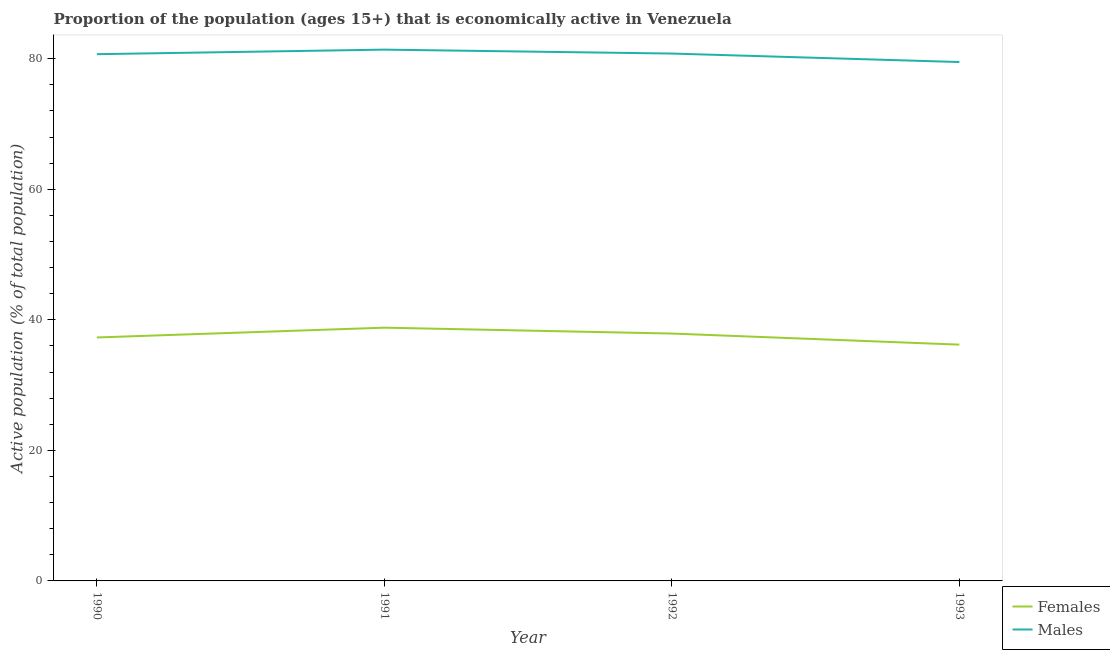What is the percentage of economically active female population in 1991?
Give a very brief answer. 38.8. Across all years, what is the maximum percentage of economically active female population?
Your answer should be very brief. 38.8. Across all years, what is the minimum percentage of economically active female population?
Ensure brevity in your answer.  36.2. In which year was the percentage of economically active male population maximum?
Ensure brevity in your answer.  1991. What is the total percentage of economically active female population in the graph?
Your answer should be very brief. 150.2. What is the difference between the percentage of economically active female population in 1990 and that in 1992?
Give a very brief answer. -0.6. What is the difference between the percentage of economically active male population in 1991 and the percentage of economically active female population in 1993?
Your answer should be compact. 45.2. What is the average percentage of economically active male population per year?
Ensure brevity in your answer.  80.6. In the year 1991, what is the difference between the percentage of economically active female population and percentage of economically active male population?
Make the answer very short. -42.6. What is the ratio of the percentage of economically active male population in 1990 to that in 1993?
Make the answer very short. 1.02. What is the difference between the highest and the second highest percentage of economically active female population?
Make the answer very short. 0.9. What is the difference between the highest and the lowest percentage of economically active female population?
Provide a succinct answer. 2.6. Is the percentage of economically active female population strictly greater than the percentage of economically active male population over the years?
Your answer should be compact. No. Is the percentage of economically active female population strictly less than the percentage of economically active male population over the years?
Keep it short and to the point. Yes. How many lines are there?
Provide a short and direct response. 2. What is the difference between two consecutive major ticks on the Y-axis?
Provide a succinct answer. 20. Are the values on the major ticks of Y-axis written in scientific E-notation?
Provide a short and direct response. No. Does the graph contain any zero values?
Provide a short and direct response. No. Does the graph contain grids?
Offer a very short reply. No. Where does the legend appear in the graph?
Your response must be concise. Bottom right. How many legend labels are there?
Ensure brevity in your answer.  2. How are the legend labels stacked?
Make the answer very short. Vertical. What is the title of the graph?
Your response must be concise. Proportion of the population (ages 15+) that is economically active in Venezuela. Does "Manufacturing industries and construction" appear as one of the legend labels in the graph?
Provide a short and direct response. No. What is the label or title of the X-axis?
Offer a very short reply. Year. What is the label or title of the Y-axis?
Give a very brief answer. Active population (% of total population). What is the Active population (% of total population) of Females in 1990?
Offer a very short reply. 37.3. What is the Active population (% of total population) of Males in 1990?
Your answer should be very brief. 80.7. What is the Active population (% of total population) in Females in 1991?
Keep it short and to the point. 38.8. What is the Active population (% of total population) in Males in 1991?
Offer a terse response. 81.4. What is the Active population (% of total population) of Females in 1992?
Provide a short and direct response. 37.9. What is the Active population (% of total population) in Males in 1992?
Your answer should be very brief. 80.8. What is the Active population (% of total population) of Females in 1993?
Offer a very short reply. 36.2. What is the Active population (% of total population) in Males in 1993?
Give a very brief answer. 79.5. Across all years, what is the maximum Active population (% of total population) of Females?
Offer a very short reply. 38.8. Across all years, what is the maximum Active population (% of total population) in Males?
Ensure brevity in your answer.  81.4. Across all years, what is the minimum Active population (% of total population) in Females?
Your response must be concise. 36.2. Across all years, what is the minimum Active population (% of total population) in Males?
Ensure brevity in your answer.  79.5. What is the total Active population (% of total population) in Females in the graph?
Keep it short and to the point. 150.2. What is the total Active population (% of total population) of Males in the graph?
Ensure brevity in your answer.  322.4. What is the difference between the Active population (% of total population) in Females in 1990 and that in 1991?
Your answer should be compact. -1.5. What is the difference between the Active population (% of total population) in Males in 1990 and that in 1992?
Give a very brief answer. -0.1. What is the difference between the Active population (% of total population) of Females in 1990 and that in 1993?
Ensure brevity in your answer.  1.1. What is the difference between the Active population (% of total population) in Females in 1991 and that in 1992?
Your answer should be very brief. 0.9. What is the difference between the Active population (% of total population) in Males in 1991 and that in 1992?
Offer a very short reply. 0.6. What is the difference between the Active population (% of total population) in Females in 1991 and that in 1993?
Provide a succinct answer. 2.6. What is the difference between the Active population (% of total population) in Males in 1992 and that in 1993?
Your answer should be compact. 1.3. What is the difference between the Active population (% of total population) in Females in 1990 and the Active population (% of total population) in Males in 1991?
Provide a succinct answer. -44.1. What is the difference between the Active population (% of total population) of Females in 1990 and the Active population (% of total population) of Males in 1992?
Your answer should be very brief. -43.5. What is the difference between the Active population (% of total population) in Females in 1990 and the Active population (% of total population) in Males in 1993?
Keep it short and to the point. -42.2. What is the difference between the Active population (% of total population) in Females in 1991 and the Active population (% of total population) in Males in 1992?
Your answer should be very brief. -42. What is the difference between the Active population (% of total population) in Females in 1991 and the Active population (% of total population) in Males in 1993?
Ensure brevity in your answer.  -40.7. What is the difference between the Active population (% of total population) in Females in 1992 and the Active population (% of total population) in Males in 1993?
Your answer should be very brief. -41.6. What is the average Active population (% of total population) of Females per year?
Provide a succinct answer. 37.55. What is the average Active population (% of total population) of Males per year?
Provide a short and direct response. 80.6. In the year 1990, what is the difference between the Active population (% of total population) in Females and Active population (% of total population) in Males?
Your answer should be very brief. -43.4. In the year 1991, what is the difference between the Active population (% of total population) of Females and Active population (% of total population) of Males?
Give a very brief answer. -42.6. In the year 1992, what is the difference between the Active population (% of total population) of Females and Active population (% of total population) of Males?
Give a very brief answer. -42.9. In the year 1993, what is the difference between the Active population (% of total population) in Females and Active population (% of total population) in Males?
Give a very brief answer. -43.3. What is the ratio of the Active population (% of total population) of Females in 1990 to that in 1991?
Keep it short and to the point. 0.96. What is the ratio of the Active population (% of total population) of Males in 1990 to that in 1991?
Offer a very short reply. 0.99. What is the ratio of the Active population (% of total population) in Females in 1990 to that in 1992?
Ensure brevity in your answer.  0.98. What is the ratio of the Active population (% of total population) in Males in 1990 to that in 1992?
Provide a succinct answer. 1. What is the ratio of the Active population (% of total population) of Females in 1990 to that in 1993?
Your answer should be very brief. 1.03. What is the ratio of the Active population (% of total population) in Males in 1990 to that in 1993?
Keep it short and to the point. 1.02. What is the ratio of the Active population (% of total population) of Females in 1991 to that in 1992?
Provide a short and direct response. 1.02. What is the ratio of the Active population (% of total population) of Males in 1991 to that in 1992?
Your response must be concise. 1.01. What is the ratio of the Active population (% of total population) of Females in 1991 to that in 1993?
Keep it short and to the point. 1.07. What is the ratio of the Active population (% of total population) of Males in 1991 to that in 1993?
Provide a short and direct response. 1.02. What is the ratio of the Active population (% of total population) in Females in 1992 to that in 1993?
Provide a succinct answer. 1.05. What is the ratio of the Active population (% of total population) of Males in 1992 to that in 1993?
Your answer should be compact. 1.02. What is the difference between the highest and the second highest Active population (% of total population) in Males?
Give a very brief answer. 0.6. 